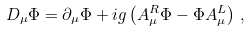<formula> <loc_0><loc_0><loc_500><loc_500>D _ { \mu } \Phi = \partial _ { \mu } \Phi + i g \left ( A ^ { R } _ { \mu } \Phi - \Phi A ^ { L } _ { \mu } \right ) \, ,</formula> 